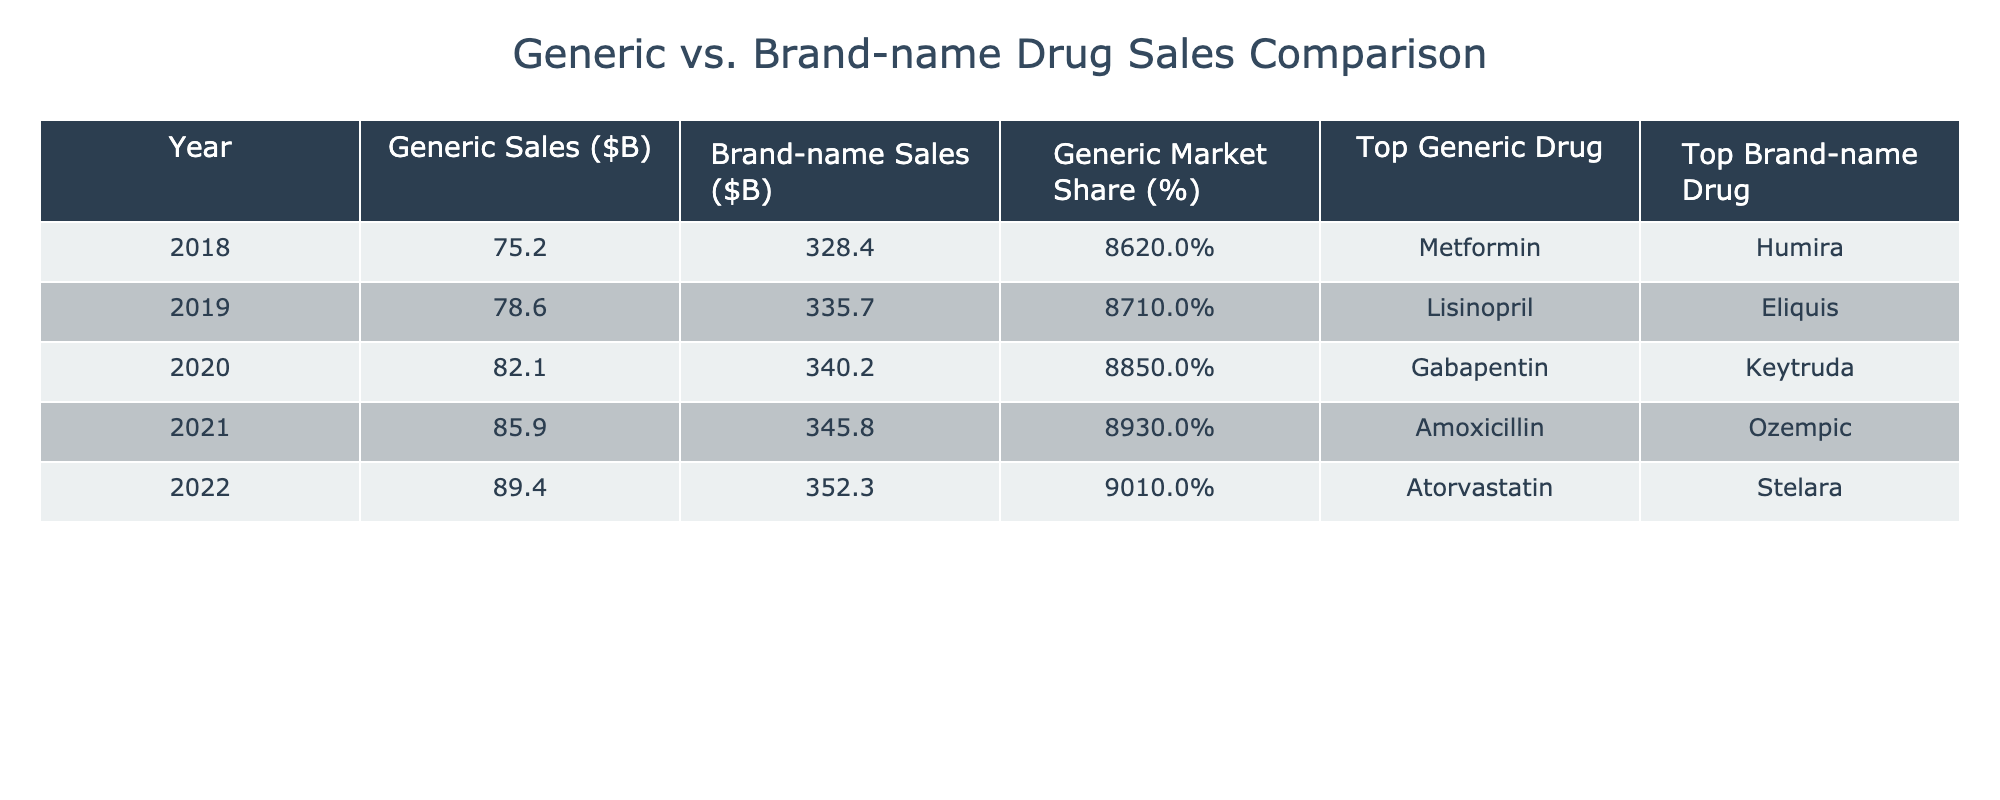What were the generic sales in 2020? Referring to the table, the entry for the year 2020 under "Generic Sales ($B)" shows a value of 82.1.
Answer: 82.1 Which year had the highest brand-name drug sales? Looking at the "Brand-name Sales ($B)" column, the year 2022 has the highest value, which is 352.3.
Answer: 2022 What was the generic market share percentage in 2019? The table indicates that the "Generic Market Share (%)" for 2019 is 87.1%.
Answer: 87.1% In which year did generic sales exceed 80 billion dollars for the first time? By examining the "Generic Sales ($B)" values, generic sales first exceeded 80 billion in the year 2020, which recorded 82.1 billion.
Answer: 2020 What was the difference in generic sales between 2018 and 2022? The generic sales in 2018 were 75.2 billion, and in 2022, they were 89.4 billion. The difference is 89.4 - 75.2 = 14.2 billion.
Answer: 14.2 billion Which generic drug had the highest sales in 2021? According to the "Top Generic Drug" column for 2021, the highest selling generic was Amoxicillin.
Answer: Amoxicillin What is the average generic market share over the 5 years? The generic market share percentages in the table are 86.2, 87.1, 88.5, 89.3, and 90.1. Summing these gives 431.2, and dividing by 5 results in an average of 86.24%.
Answer: 86.24% Did more than 80 billion dollars in generic sales occur every year from 2018 to 2022? From the table, only in 2020, 2021, and 2022 did generic sales surpass 80 billion dollars. Therefore, it is false that sales exceeded this amount every year.
Answer: No What was the top brand-name drug in 2020, and what was its sales figure? In the year 2020, the "Top Brand-name Drug" is Keytruda, which had sales of 340.2 billion dollars.
Answer: Keytruda, $340.2B Which year experienced the largest increase in brand-name sales compared to the previous year? By calculating the differences in brand-name sales for each year, the largest increase was from 2021 to 2022: 352.3 - 345.8 = 6.5 billion.
Answer: 6.5 billion from 2021 to 2022 